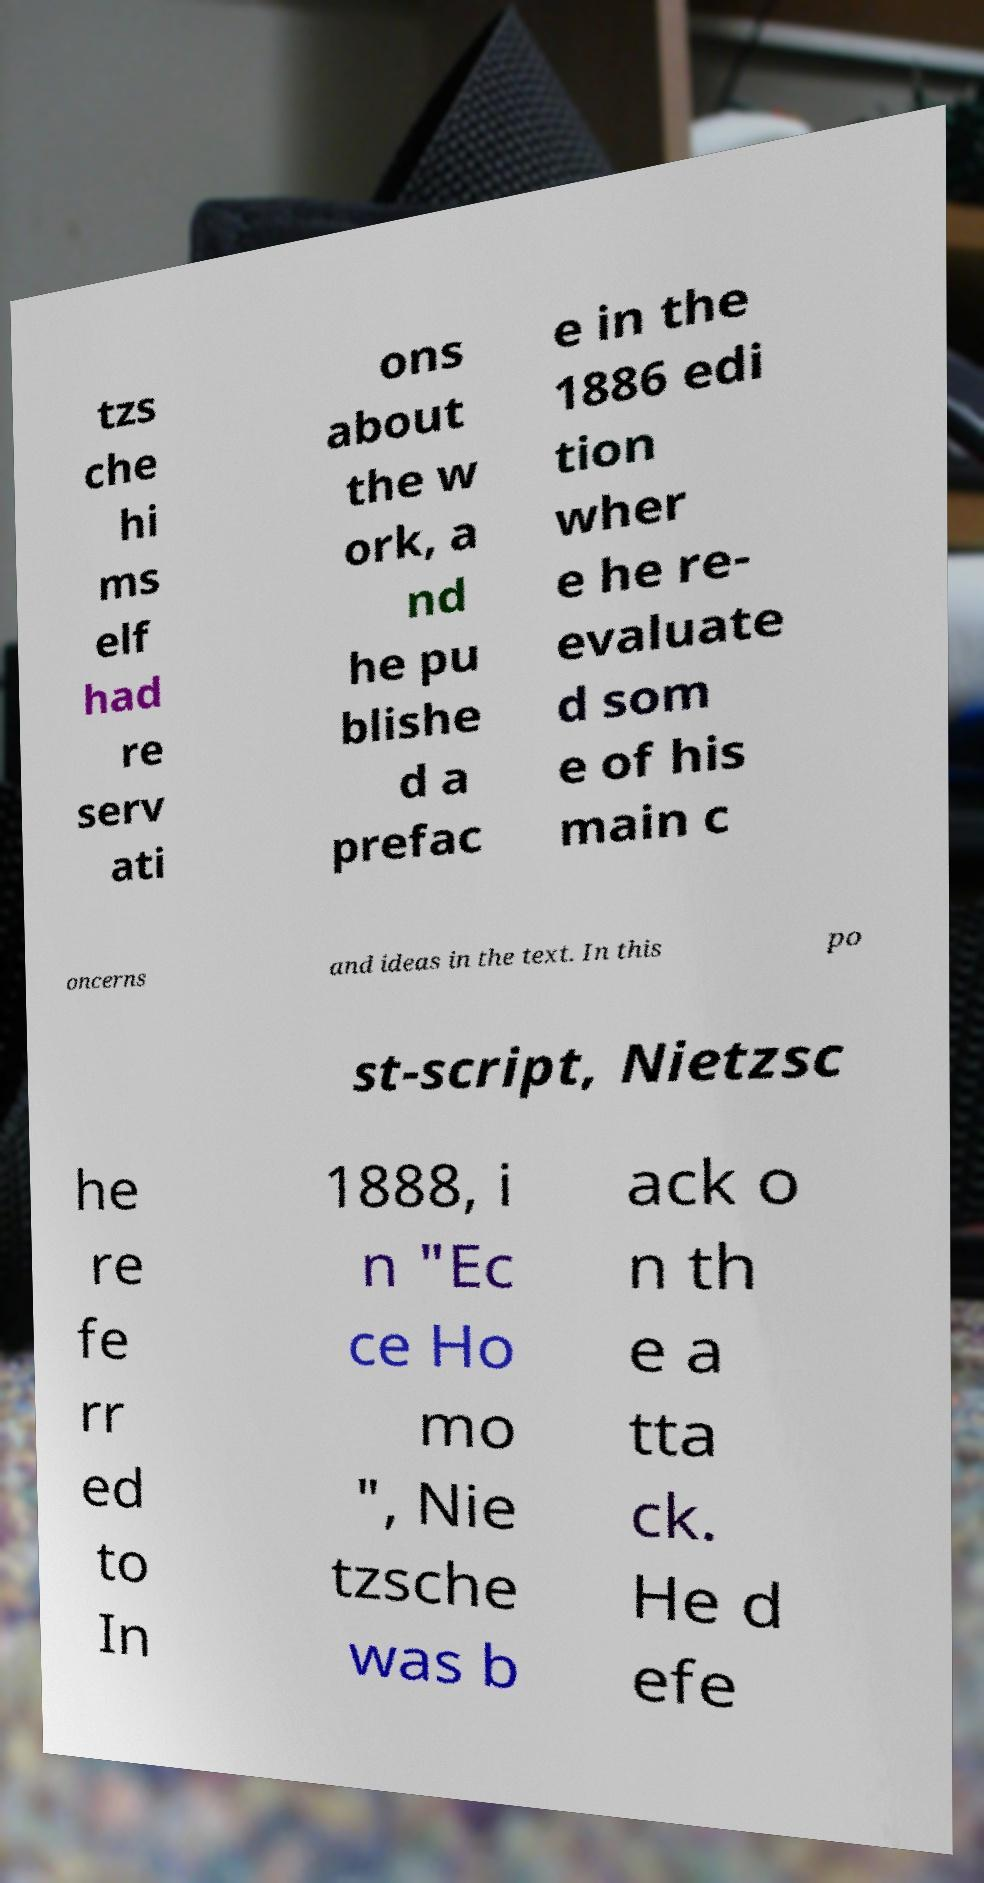What messages or text are displayed in this image? I need them in a readable, typed format. tzs che hi ms elf had re serv ati ons about the w ork, a nd he pu blishe d a prefac e in the 1886 edi tion wher e he re- evaluate d som e of his main c oncerns and ideas in the text. In this po st-script, Nietzsc he re fe rr ed to In 1888, i n "Ec ce Ho mo ", Nie tzsche was b ack o n th e a tta ck. He d efe 